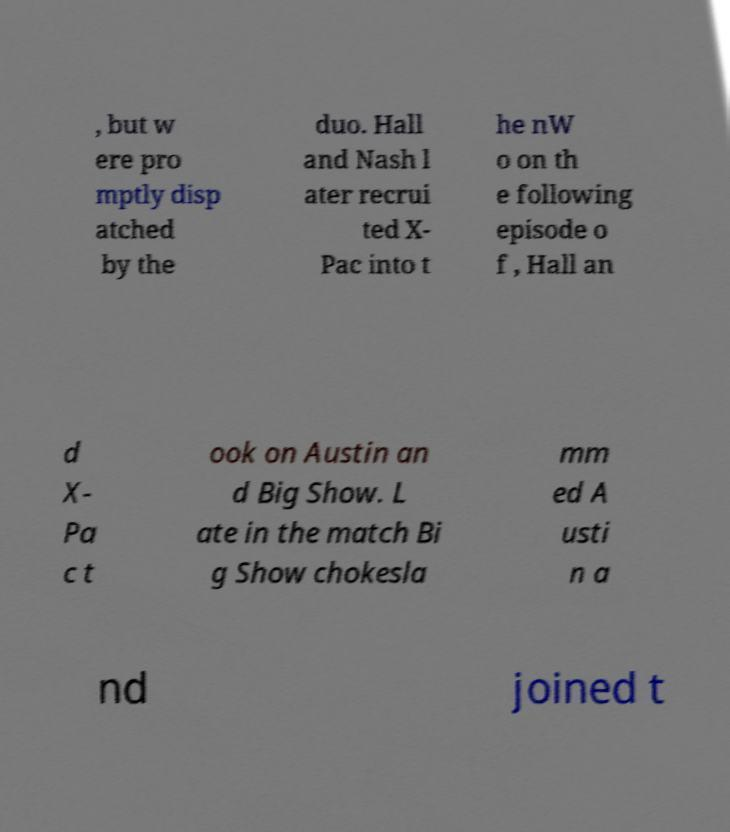Please read and relay the text visible in this image. What does it say? , but w ere pro mptly disp atched by the duo. Hall and Nash l ater recrui ted X- Pac into t he nW o on th e following episode o f , Hall an d X- Pa c t ook on Austin an d Big Show. L ate in the match Bi g Show chokesla mm ed A usti n a nd joined t 